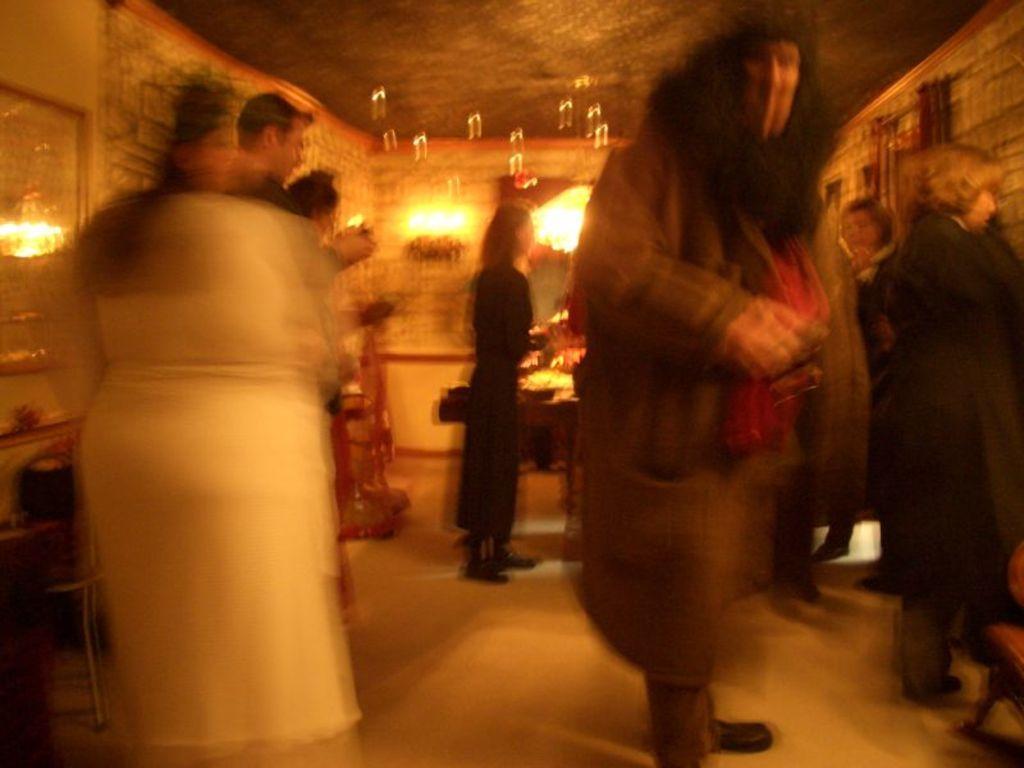How would you summarize this image in a sentence or two? In this image, I can see few people standing on the floor. In the background there are lights, a table and few other objects. On the left side of the image, I can see a chair and a photo frame attached to the wall. 